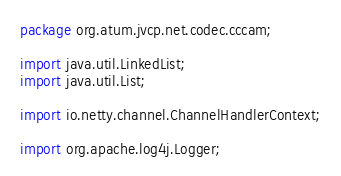Convert code to text. <code><loc_0><loc_0><loc_500><loc_500><_Java_>package org.atum.jvcp.net.codec.cccam;

import java.util.LinkedList;
import java.util.List;

import io.netty.channel.ChannelHandlerContext;

import org.apache.log4j.Logger;</code> 